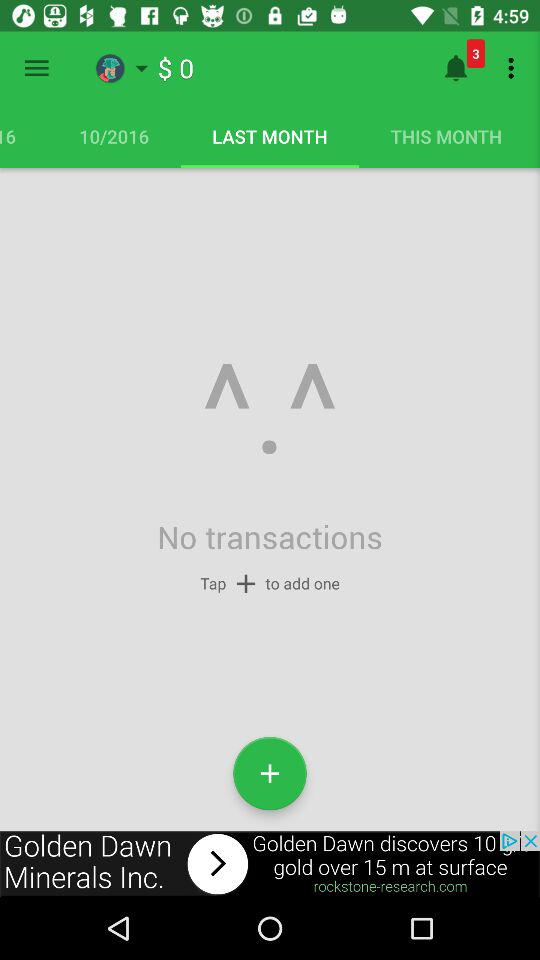Are there any transactions? There are no transactions. 